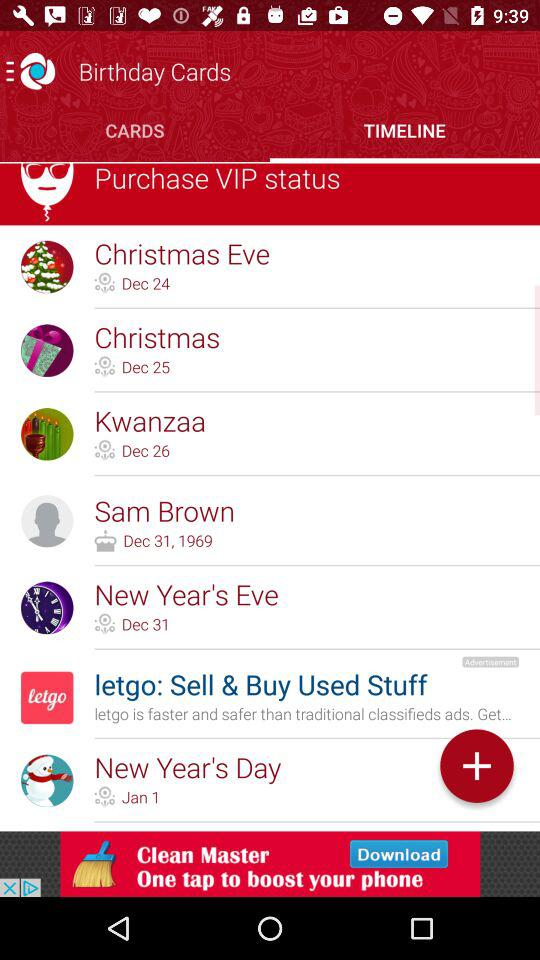What is the Christmas date? The Christmas date is December 25. 